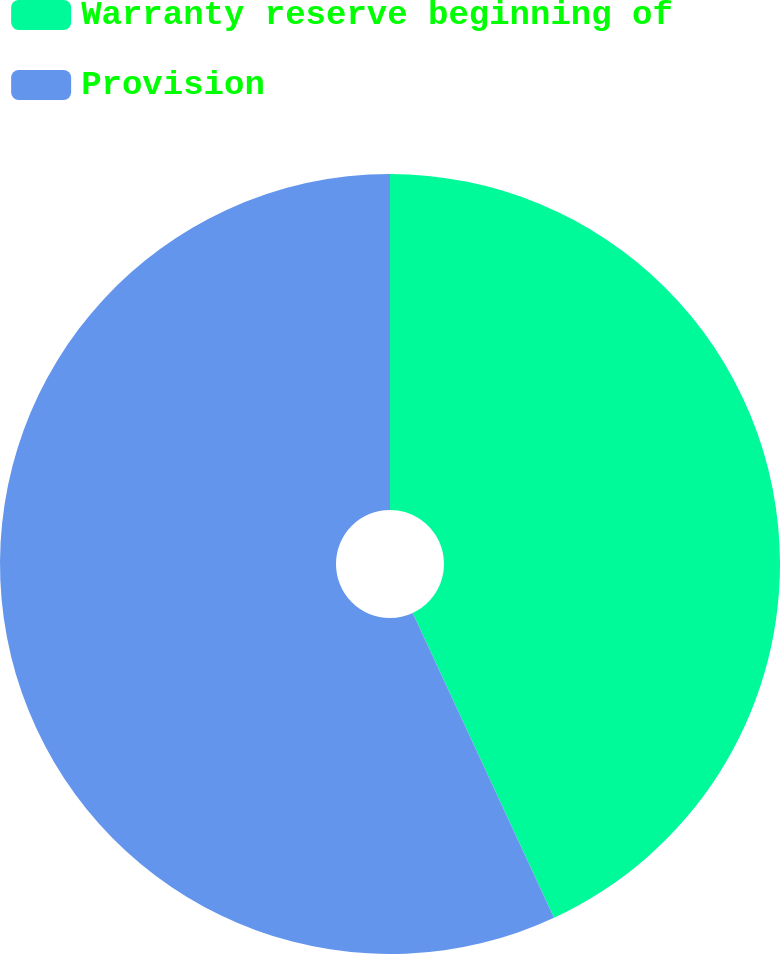Convert chart to OTSL. <chart><loc_0><loc_0><loc_500><loc_500><pie_chart><fcel>Warranty reserve beginning of<fcel>Provision<nl><fcel>43.09%<fcel>56.91%<nl></chart> 